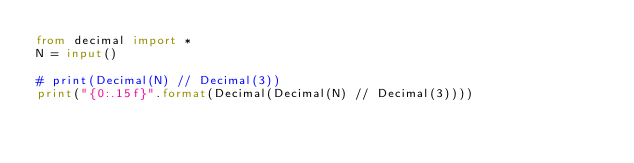Convert code to text. <code><loc_0><loc_0><loc_500><loc_500><_Python_>from decimal import *
N = input()

# print(Decimal(N) // Decimal(3))
print("{0:.15f}".format(Decimal(Decimal(N) // Decimal(3))))</code> 